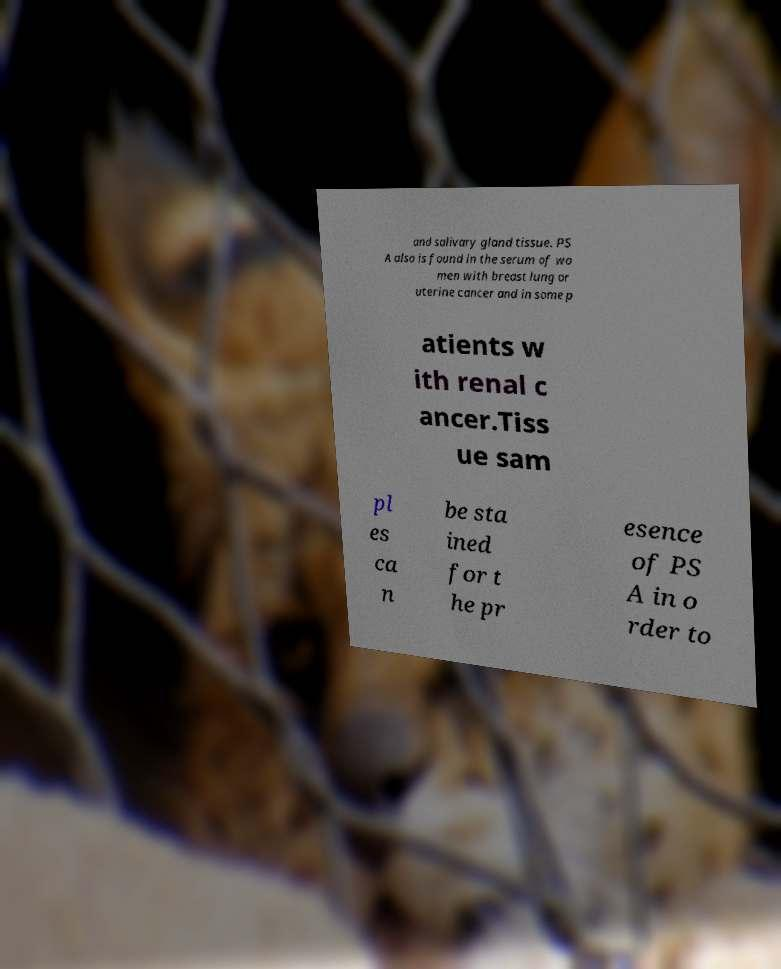Please identify and transcribe the text found in this image. and salivary gland tissue. PS A also is found in the serum of wo men with breast lung or uterine cancer and in some p atients w ith renal c ancer.Tiss ue sam pl es ca n be sta ined for t he pr esence of PS A in o rder to 